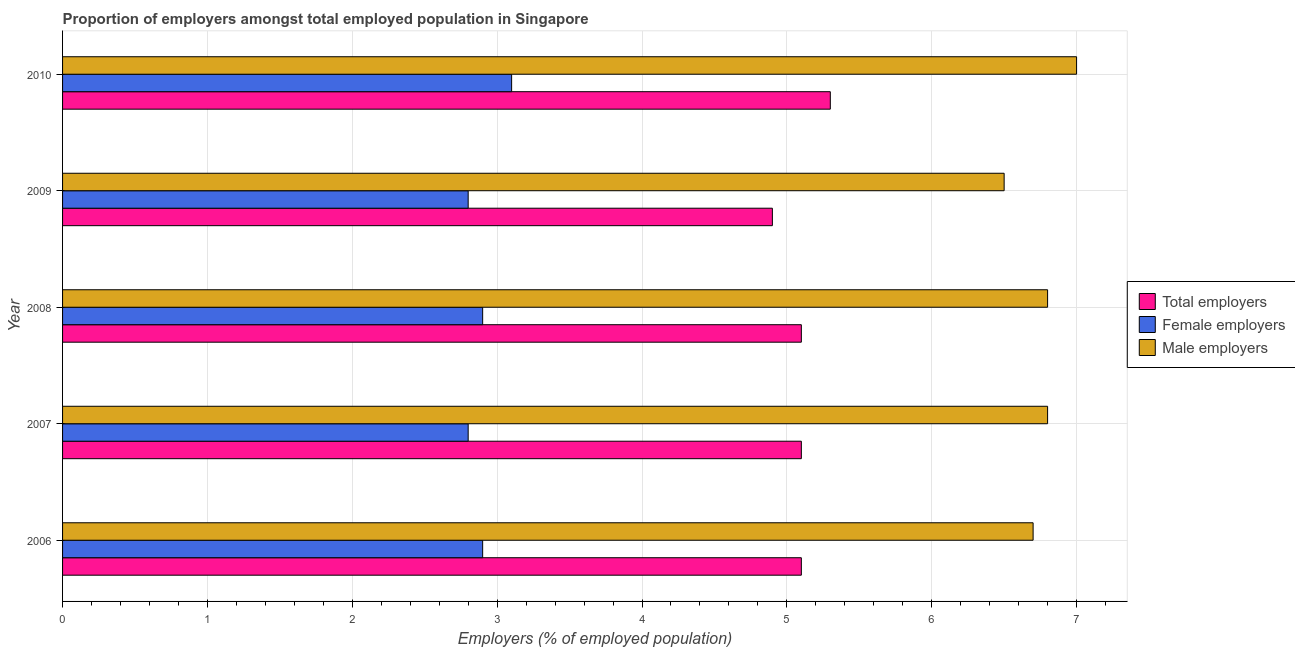How many different coloured bars are there?
Offer a very short reply. 3. How many groups of bars are there?
Provide a short and direct response. 5. What is the percentage of female employers in 2010?
Make the answer very short. 3.1. Across all years, what is the maximum percentage of total employers?
Give a very brief answer. 5.3. Across all years, what is the minimum percentage of female employers?
Ensure brevity in your answer.  2.8. In which year was the percentage of female employers maximum?
Offer a terse response. 2010. In which year was the percentage of female employers minimum?
Your response must be concise. 2007. What is the total percentage of male employers in the graph?
Provide a succinct answer. 33.8. What is the difference between the percentage of male employers in 2007 and that in 2009?
Keep it short and to the point. 0.3. What is the difference between the percentage of male employers in 2006 and the percentage of female employers in 2010?
Provide a succinct answer. 3.6. What is the average percentage of male employers per year?
Give a very brief answer. 6.76. In the year 2006, what is the difference between the percentage of female employers and percentage of total employers?
Your response must be concise. -2.2. In how many years, is the percentage of female employers greater than 0.4 %?
Your response must be concise. 5. What is the ratio of the percentage of total employers in 2006 to that in 2008?
Make the answer very short. 1. Is the percentage of female employers in 2006 less than that in 2007?
Your response must be concise. No. Is the difference between the percentage of male employers in 2008 and 2009 greater than the difference between the percentage of total employers in 2008 and 2009?
Give a very brief answer. Yes. What is the difference between the highest and the second highest percentage of total employers?
Your response must be concise. 0.2. What is the difference between the highest and the lowest percentage of total employers?
Keep it short and to the point. 0.4. What does the 2nd bar from the top in 2010 represents?
Your answer should be very brief. Female employers. What does the 1st bar from the bottom in 2006 represents?
Provide a succinct answer. Total employers. Are all the bars in the graph horizontal?
Offer a very short reply. Yes. What is the difference between two consecutive major ticks on the X-axis?
Your answer should be compact. 1. Does the graph contain grids?
Give a very brief answer. Yes. Where does the legend appear in the graph?
Provide a succinct answer. Center right. How many legend labels are there?
Offer a terse response. 3. What is the title of the graph?
Provide a succinct answer. Proportion of employers amongst total employed population in Singapore. Does "Communicable diseases" appear as one of the legend labels in the graph?
Your answer should be compact. No. What is the label or title of the X-axis?
Give a very brief answer. Employers (% of employed population). What is the label or title of the Y-axis?
Offer a terse response. Year. What is the Employers (% of employed population) in Total employers in 2006?
Your answer should be compact. 5.1. What is the Employers (% of employed population) in Female employers in 2006?
Ensure brevity in your answer.  2.9. What is the Employers (% of employed population) of Male employers in 2006?
Offer a very short reply. 6.7. What is the Employers (% of employed population) in Total employers in 2007?
Your answer should be compact. 5.1. What is the Employers (% of employed population) in Female employers in 2007?
Offer a terse response. 2.8. What is the Employers (% of employed population) of Male employers in 2007?
Provide a succinct answer. 6.8. What is the Employers (% of employed population) of Total employers in 2008?
Provide a short and direct response. 5.1. What is the Employers (% of employed population) in Female employers in 2008?
Keep it short and to the point. 2.9. What is the Employers (% of employed population) in Male employers in 2008?
Offer a terse response. 6.8. What is the Employers (% of employed population) in Total employers in 2009?
Make the answer very short. 4.9. What is the Employers (% of employed population) of Female employers in 2009?
Ensure brevity in your answer.  2.8. What is the Employers (% of employed population) of Male employers in 2009?
Make the answer very short. 6.5. What is the Employers (% of employed population) in Total employers in 2010?
Your response must be concise. 5.3. What is the Employers (% of employed population) in Female employers in 2010?
Give a very brief answer. 3.1. Across all years, what is the maximum Employers (% of employed population) of Total employers?
Your answer should be compact. 5.3. Across all years, what is the maximum Employers (% of employed population) in Female employers?
Keep it short and to the point. 3.1. Across all years, what is the maximum Employers (% of employed population) of Male employers?
Ensure brevity in your answer.  7. Across all years, what is the minimum Employers (% of employed population) of Total employers?
Your answer should be very brief. 4.9. Across all years, what is the minimum Employers (% of employed population) in Female employers?
Provide a short and direct response. 2.8. What is the total Employers (% of employed population) of Female employers in the graph?
Provide a short and direct response. 14.5. What is the total Employers (% of employed population) in Male employers in the graph?
Provide a short and direct response. 33.8. What is the difference between the Employers (% of employed population) in Total employers in 2006 and that in 2007?
Give a very brief answer. 0. What is the difference between the Employers (% of employed population) in Female employers in 2006 and that in 2007?
Ensure brevity in your answer.  0.1. What is the difference between the Employers (% of employed population) of Male employers in 2006 and that in 2007?
Offer a very short reply. -0.1. What is the difference between the Employers (% of employed population) in Female employers in 2006 and that in 2008?
Your answer should be very brief. 0. What is the difference between the Employers (% of employed population) of Male employers in 2006 and that in 2008?
Your answer should be compact. -0.1. What is the difference between the Employers (% of employed population) of Female employers in 2006 and that in 2009?
Your answer should be very brief. 0.1. What is the difference between the Employers (% of employed population) of Male employers in 2006 and that in 2010?
Provide a succinct answer. -0.3. What is the difference between the Employers (% of employed population) in Female employers in 2007 and that in 2008?
Your answer should be very brief. -0.1. What is the difference between the Employers (% of employed population) in Male employers in 2007 and that in 2009?
Offer a terse response. 0.3. What is the difference between the Employers (% of employed population) of Total employers in 2007 and that in 2010?
Offer a very short reply. -0.2. What is the difference between the Employers (% of employed population) of Male employers in 2007 and that in 2010?
Make the answer very short. -0.2. What is the difference between the Employers (% of employed population) of Total employers in 2008 and that in 2009?
Your answer should be very brief. 0.2. What is the difference between the Employers (% of employed population) of Female employers in 2008 and that in 2009?
Your response must be concise. 0.1. What is the difference between the Employers (% of employed population) of Total employers in 2008 and that in 2010?
Offer a very short reply. -0.2. What is the difference between the Employers (% of employed population) of Total employers in 2006 and the Employers (% of employed population) of Male employers in 2007?
Make the answer very short. -1.7. What is the difference between the Employers (% of employed population) in Female employers in 2006 and the Employers (% of employed population) in Male employers in 2007?
Provide a short and direct response. -3.9. What is the difference between the Employers (% of employed population) of Female employers in 2006 and the Employers (% of employed population) of Male employers in 2008?
Keep it short and to the point. -3.9. What is the difference between the Employers (% of employed population) of Total employers in 2006 and the Employers (% of employed population) of Female employers in 2009?
Provide a succinct answer. 2.3. What is the difference between the Employers (% of employed population) of Total employers in 2006 and the Employers (% of employed population) of Male employers in 2009?
Provide a succinct answer. -1.4. What is the difference between the Employers (% of employed population) in Female employers in 2006 and the Employers (% of employed population) in Male employers in 2009?
Provide a short and direct response. -3.6. What is the difference between the Employers (% of employed population) of Total employers in 2006 and the Employers (% of employed population) of Female employers in 2010?
Keep it short and to the point. 2. What is the difference between the Employers (% of employed population) of Total employers in 2006 and the Employers (% of employed population) of Male employers in 2010?
Your answer should be compact. -1.9. What is the difference between the Employers (% of employed population) of Female employers in 2006 and the Employers (% of employed population) of Male employers in 2010?
Keep it short and to the point. -4.1. What is the difference between the Employers (% of employed population) in Female employers in 2007 and the Employers (% of employed population) in Male employers in 2008?
Make the answer very short. -4. What is the difference between the Employers (% of employed population) of Total employers in 2007 and the Employers (% of employed population) of Female employers in 2009?
Your answer should be very brief. 2.3. What is the difference between the Employers (% of employed population) in Female employers in 2007 and the Employers (% of employed population) in Male employers in 2009?
Offer a terse response. -3.7. What is the difference between the Employers (% of employed population) of Total employers in 2007 and the Employers (% of employed population) of Female employers in 2010?
Provide a short and direct response. 2. What is the difference between the Employers (% of employed population) in Total employers in 2007 and the Employers (% of employed population) in Male employers in 2010?
Give a very brief answer. -1.9. What is the difference between the Employers (% of employed population) in Total employers in 2008 and the Employers (% of employed population) in Female employers in 2010?
Ensure brevity in your answer.  2. What is the difference between the Employers (% of employed population) in Total employers in 2008 and the Employers (% of employed population) in Male employers in 2010?
Offer a terse response. -1.9. What is the difference between the Employers (% of employed population) in Female employers in 2008 and the Employers (% of employed population) in Male employers in 2010?
Your answer should be compact. -4.1. What is the difference between the Employers (% of employed population) in Total employers in 2009 and the Employers (% of employed population) in Female employers in 2010?
Your answer should be compact. 1.8. What is the difference between the Employers (% of employed population) in Female employers in 2009 and the Employers (% of employed population) in Male employers in 2010?
Offer a very short reply. -4.2. What is the average Employers (% of employed population) of Male employers per year?
Give a very brief answer. 6.76. In the year 2006, what is the difference between the Employers (% of employed population) of Total employers and Employers (% of employed population) of Female employers?
Your response must be concise. 2.2. In the year 2006, what is the difference between the Employers (% of employed population) of Total employers and Employers (% of employed population) of Male employers?
Provide a succinct answer. -1.6. In the year 2007, what is the difference between the Employers (% of employed population) of Total employers and Employers (% of employed population) of Female employers?
Provide a succinct answer. 2.3. In the year 2007, what is the difference between the Employers (% of employed population) of Total employers and Employers (% of employed population) of Male employers?
Provide a succinct answer. -1.7. In the year 2007, what is the difference between the Employers (% of employed population) of Female employers and Employers (% of employed population) of Male employers?
Ensure brevity in your answer.  -4. In the year 2008, what is the difference between the Employers (% of employed population) of Total employers and Employers (% of employed population) of Female employers?
Offer a very short reply. 2.2. In the year 2008, what is the difference between the Employers (% of employed population) of Female employers and Employers (% of employed population) of Male employers?
Your answer should be compact. -3.9. In the year 2009, what is the difference between the Employers (% of employed population) in Total employers and Employers (% of employed population) in Male employers?
Your answer should be compact. -1.6. In the year 2010, what is the difference between the Employers (% of employed population) in Total employers and Employers (% of employed population) in Female employers?
Ensure brevity in your answer.  2.2. In the year 2010, what is the difference between the Employers (% of employed population) in Female employers and Employers (% of employed population) in Male employers?
Ensure brevity in your answer.  -3.9. What is the ratio of the Employers (% of employed population) in Total employers in 2006 to that in 2007?
Your answer should be compact. 1. What is the ratio of the Employers (% of employed population) in Female employers in 2006 to that in 2007?
Provide a succinct answer. 1.04. What is the ratio of the Employers (% of employed population) in Total employers in 2006 to that in 2009?
Your answer should be very brief. 1.04. What is the ratio of the Employers (% of employed population) of Female employers in 2006 to that in 2009?
Offer a terse response. 1.04. What is the ratio of the Employers (% of employed population) of Male employers in 2006 to that in 2009?
Offer a terse response. 1.03. What is the ratio of the Employers (% of employed population) in Total employers in 2006 to that in 2010?
Make the answer very short. 0.96. What is the ratio of the Employers (% of employed population) in Female employers in 2006 to that in 2010?
Offer a very short reply. 0.94. What is the ratio of the Employers (% of employed population) of Male employers in 2006 to that in 2010?
Give a very brief answer. 0.96. What is the ratio of the Employers (% of employed population) of Total employers in 2007 to that in 2008?
Offer a very short reply. 1. What is the ratio of the Employers (% of employed population) of Female employers in 2007 to that in 2008?
Provide a short and direct response. 0.97. What is the ratio of the Employers (% of employed population) of Male employers in 2007 to that in 2008?
Your answer should be compact. 1. What is the ratio of the Employers (% of employed population) of Total employers in 2007 to that in 2009?
Provide a short and direct response. 1.04. What is the ratio of the Employers (% of employed population) of Female employers in 2007 to that in 2009?
Ensure brevity in your answer.  1. What is the ratio of the Employers (% of employed population) in Male employers in 2007 to that in 2009?
Ensure brevity in your answer.  1.05. What is the ratio of the Employers (% of employed population) of Total employers in 2007 to that in 2010?
Provide a short and direct response. 0.96. What is the ratio of the Employers (% of employed population) in Female employers in 2007 to that in 2010?
Your response must be concise. 0.9. What is the ratio of the Employers (% of employed population) of Male employers in 2007 to that in 2010?
Your answer should be very brief. 0.97. What is the ratio of the Employers (% of employed population) of Total employers in 2008 to that in 2009?
Offer a very short reply. 1.04. What is the ratio of the Employers (% of employed population) of Female employers in 2008 to that in 2009?
Offer a very short reply. 1.04. What is the ratio of the Employers (% of employed population) of Male employers in 2008 to that in 2009?
Your answer should be compact. 1.05. What is the ratio of the Employers (% of employed population) of Total employers in 2008 to that in 2010?
Your answer should be very brief. 0.96. What is the ratio of the Employers (% of employed population) of Female employers in 2008 to that in 2010?
Your answer should be compact. 0.94. What is the ratio of the Employers (% of employed population) of Male employers in 2008 to that in 2010?
Offer a very short reply. 0.97. What is the ratio of the Employers (% of employed population) in Total employers in 2009 to that in 2010?
Your answer should be very brief. 0.92. What is the ratio of the Employers (% of employed population) in Female employers in 2009 to that in 2010?
Keep it short and to the point. 0.9. What is the difference between the highest and the second highest Employers (% of employed population) in Total employers?
Keep it short and to the point. 0.2. What is the difference between the highest and the second highest Employers (% of employed population) in Female employers?
Your answer should be compact. 0.2. What is the difference between the highest and the second highest Employers (% of employed population) in Male employers?
Offer a very short reply. 0.2. What is the difference between the highest and the lowest Employers (% of employed population) of Female employers?
Give a very brief answer. 0.3. 